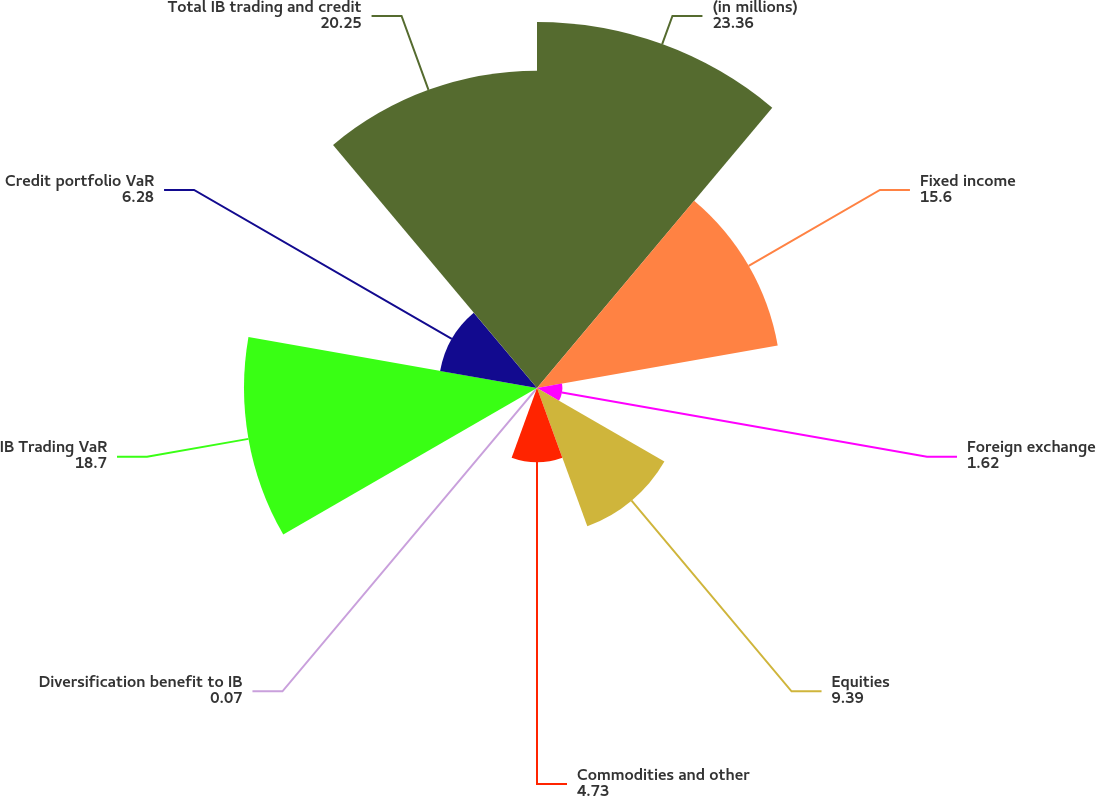Convert chart to OTSL. <chart><loc_0><loc_0><loc_500><loc_500><pie_chart><fcel>(in millions)<fcel>Fixed income<fcel>Foreign exchange<fcel>Equities<fcel>Commodities and other<fcel>Diversification benefit to IB<fcel>IB Trading VaR<fcel>Credit portfolio VaR<fcel>Total IB trading and credit<nl><fcel>23.36%<fcel>15.6%<fcel>1.62%<fcel>9.39%<fcel>4.73%<fcel>0.07%<fcel>18.7%<fcel>6.28%<fcel>20.25%<nl></chart> 